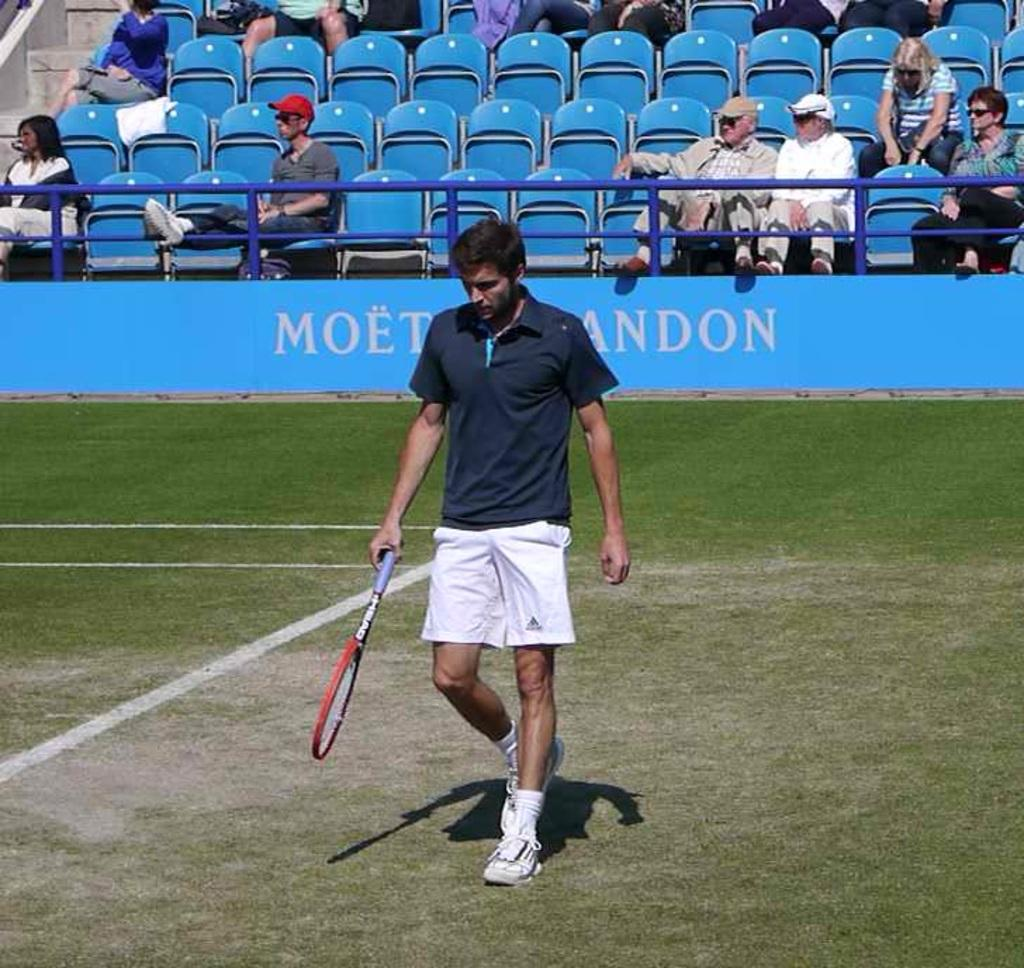Who is present in the image? There is a man in the image. What is the man holding in the image? The man is holding a tennis racket. What is the man doing in the image? The man is walking on a path. What can be seen in the background of the image? There is a board and people sitting on chairs in the background of the image. What type of eggs are being discussed by the people sitting on chairs in the image? There is no mention of eggs or any discussion in the image. The people sitting on chairs are simply present in the background. 